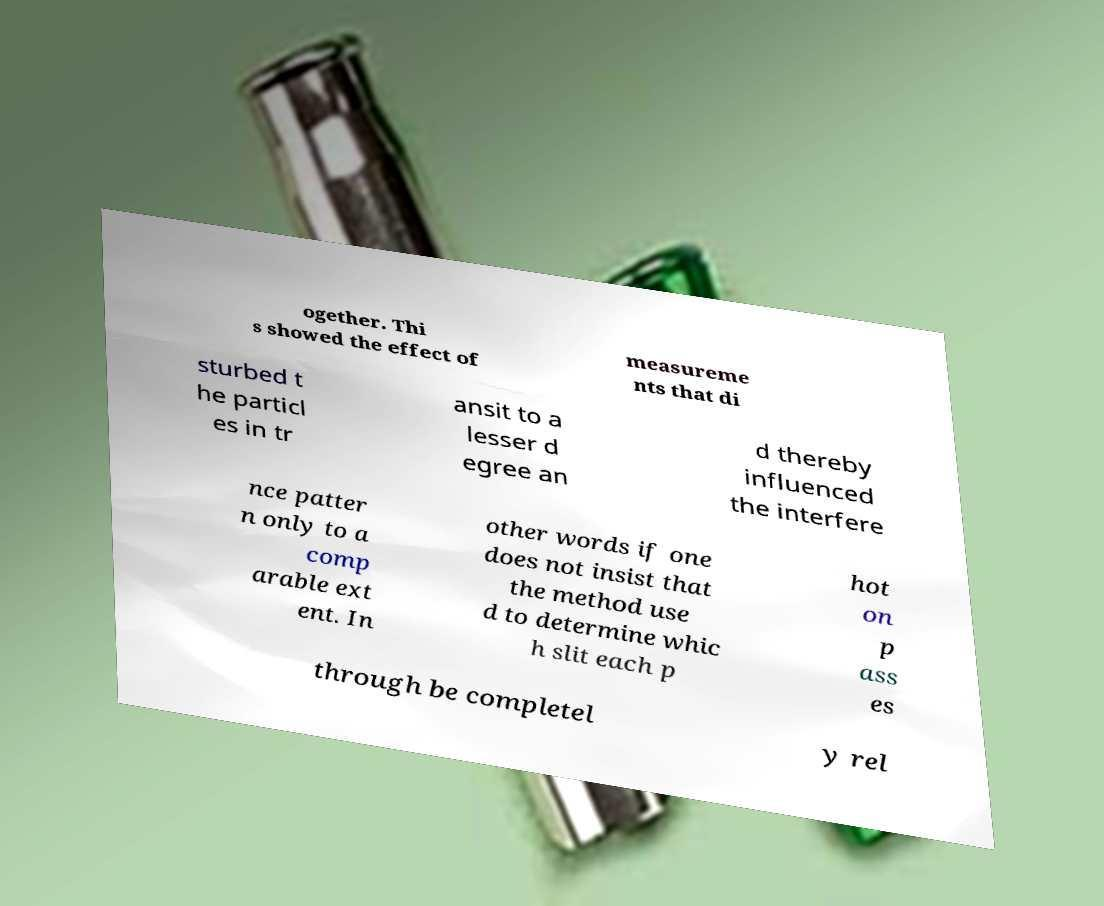For documentation purposes, I need the text within this image transcribed. Could you provide that? ogether. Thi s showed the effect of measureme nts that di sturbed t he particl es in tr ansit to a lesser d egree an d thereby influenced the interfere nce patter n only to a comp arable ext ent. In other words if one does not insist that the method use d to determine whic h slit each p hot on p ass es through be completel y rel 